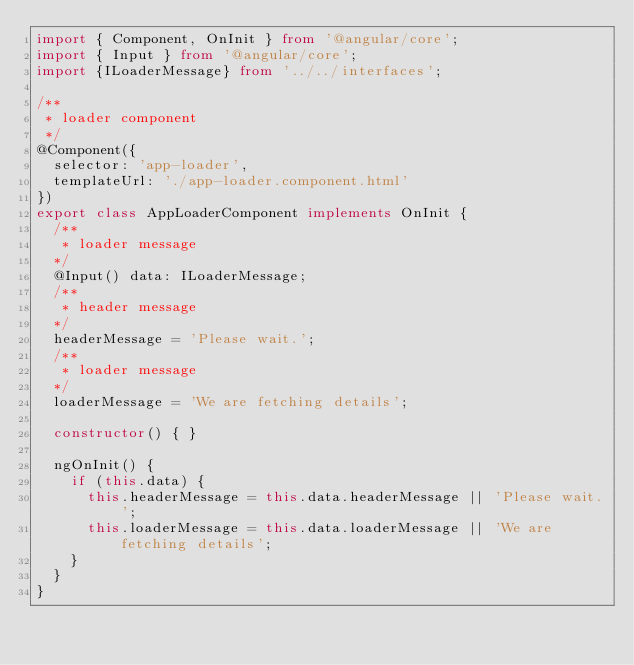Convert code to text. <code><loc_0><loc_0><loc_500><loc_500><_TypeScript_>import { Component, OnInit } from '@angular/core';
import { Input } from '@angular/core';
import {ILoaderMessage} from '../../interfaces';

/**
 * loader component
 */
@Component({
  selector: 'app-loader',
  templateUrl: './app-loader.component.html'
})
export class AppLoaderComponent implements OnInit {
  /**
   * loader message
  */
  @Input() data: ILoaderMessage;
  /**
   * header message
  */
  headerMessage = 'Please wait.';
  /**
   * loader message
  */
  loaderMessage = 'We are fetching details';

  constructor() { }

  ngOnInit() {
    if (this.data) {
      this.headerMessage = this.data.headerMessage || 'Please wait.';
      this.loaderMessage = this.data.loaderMessage || 'We are fetching details';
    }
  }
}
</code> 